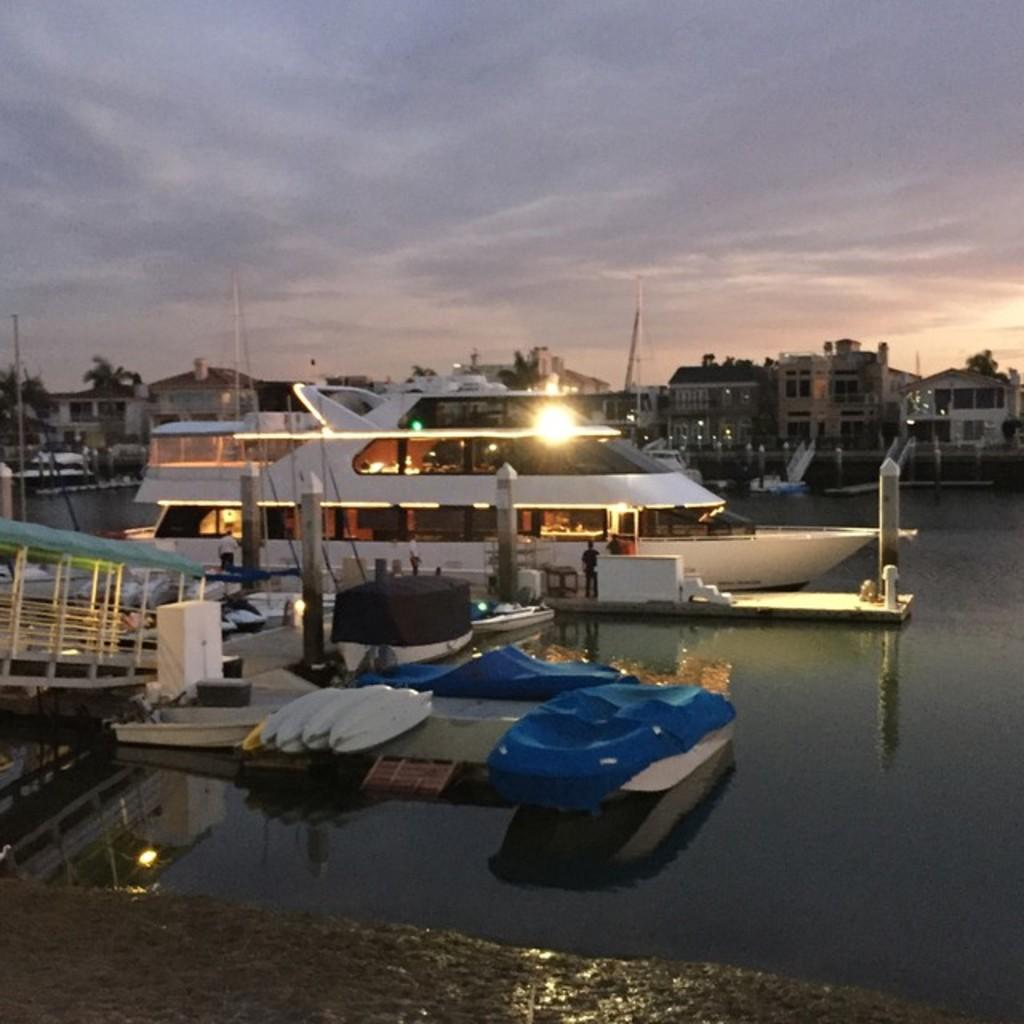What is located in the foreground of the image? There are boats and a ship near a dock in the foreground of the image. Can you describe the ship in the foreground? The ship in the foreground is near a dock. What is visible in the background of the image? There is a ship on the water, buildings, and the sky visible in the background of the image. What can be seen in the sky? The sky has clouds in it. What type of plant can be seen growing in the lunchroom in the image? There is no lunchroom or plant present in the image. 